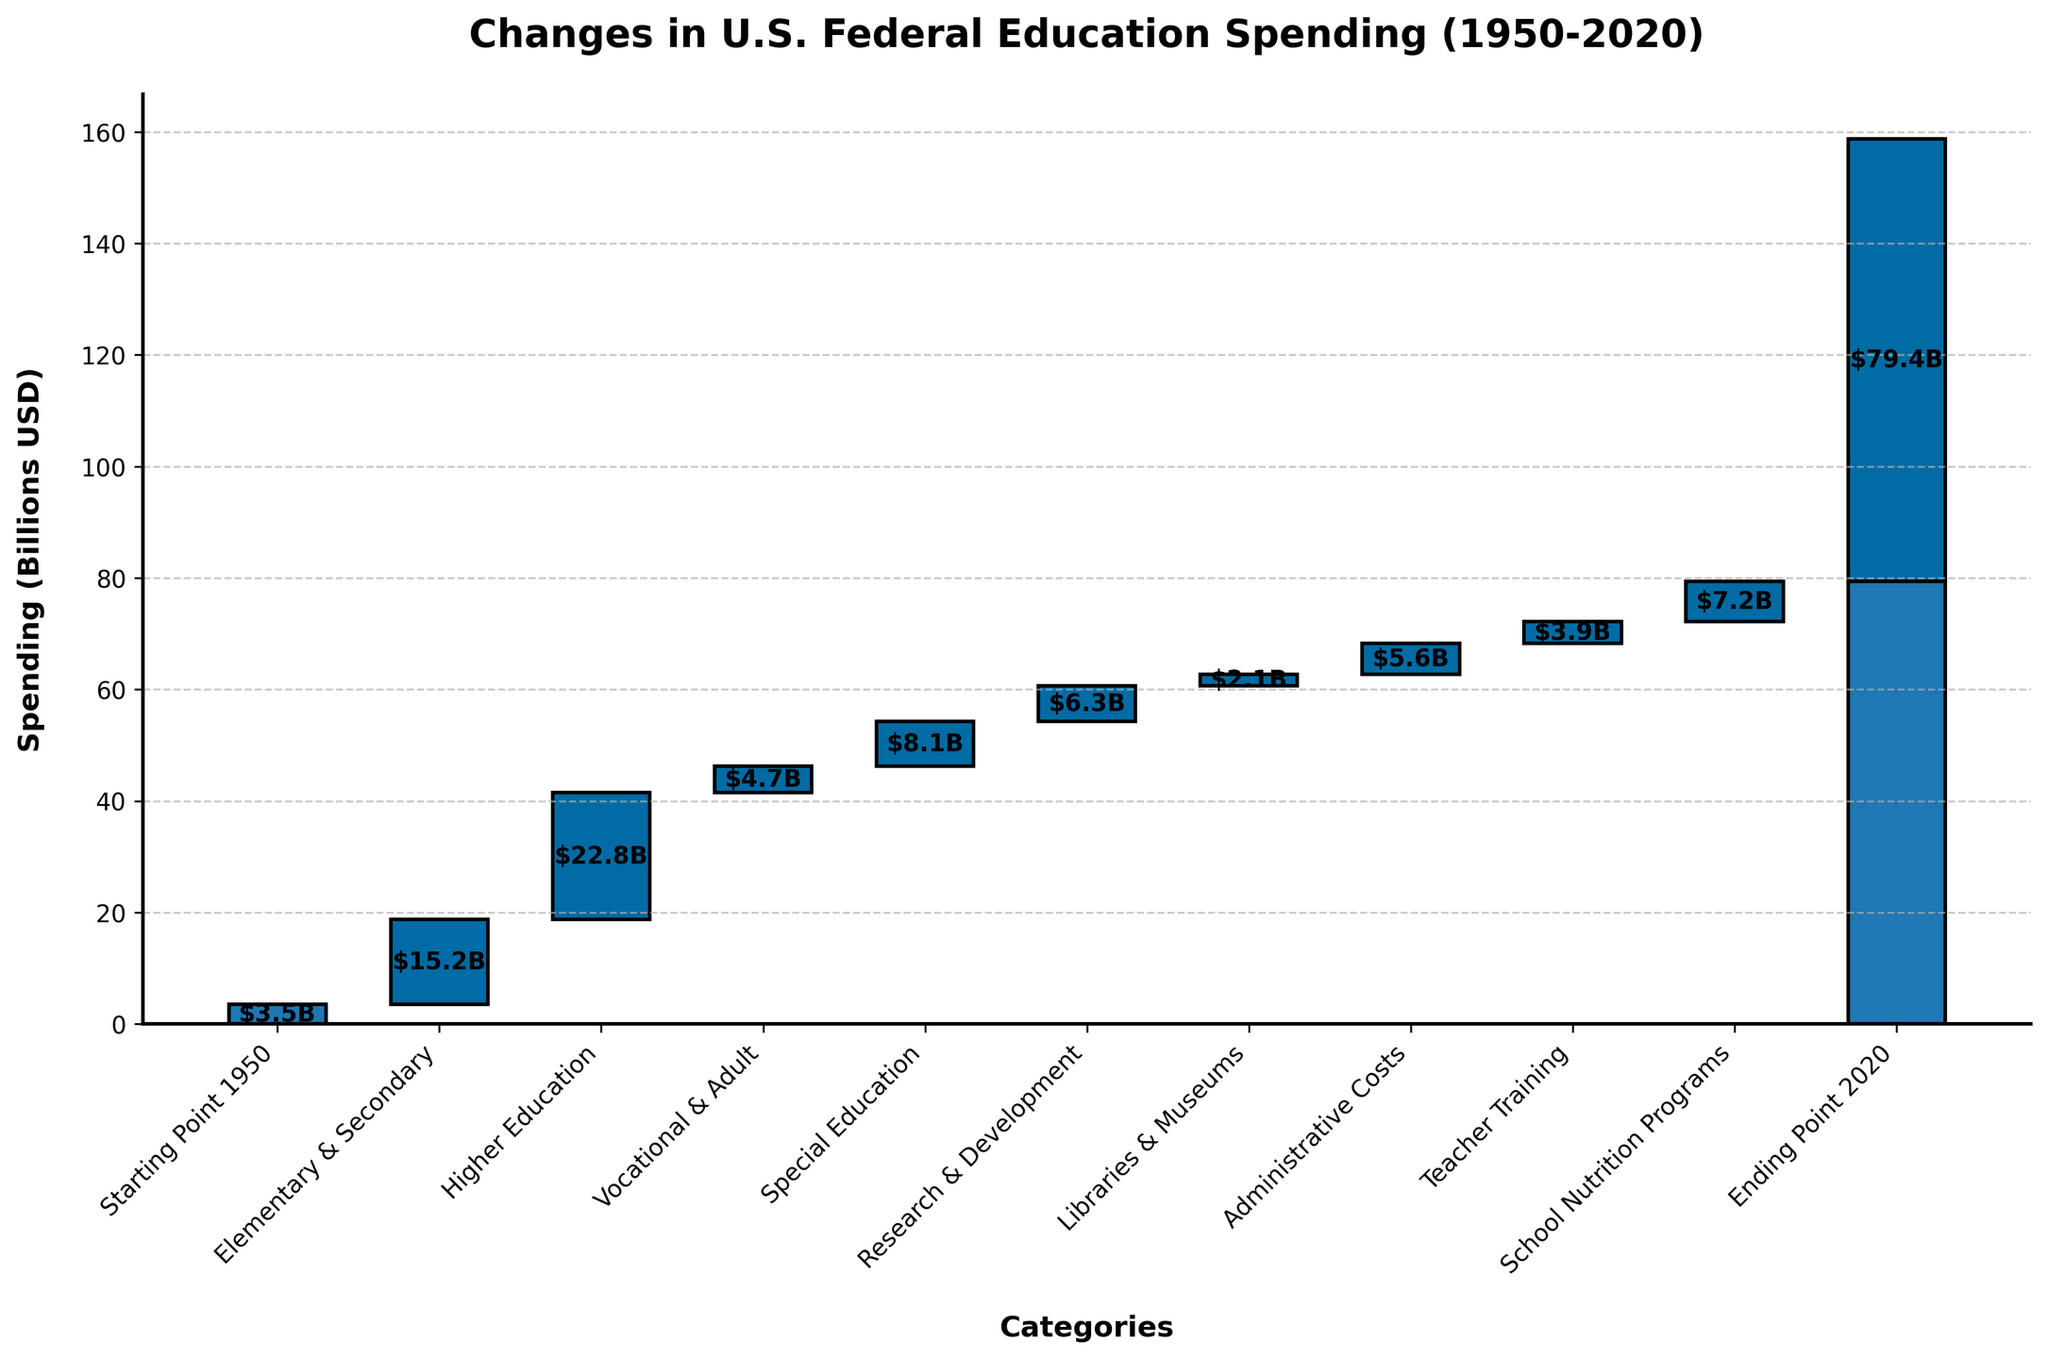What's the title of the chart? The title of the chart is displayed at the top of the figure. It provides the main description of what the chart is about.
Answer: Changes in U.S. Federal Education Spending (1950-2020) What are the starting and ending points of the spending from 1950 to 2020? The starting and ending points can be identified from the first and last bars which are likely highlighted in a different color.
Answer: $3.5B and $79.4B Which educational level category had the highest increase in spending? We look for the bar with the highest value among the categories listed.
Answer: Higher Education What is the cumulative spending for Elementary & Secondary and Higher Education? Find the values for "Elementary & Secondary" and "Higher Education", and sum them up: $15.2B + $22.8B.
Answer: $38.0B How much more was spent on Special Education than on Libraries & Museums? Subtract the spending on "Libraries & Museums" from "Special Education": $8.1B - $2.1B.
Answer: $6.0B Among Administrative Costs and Teacher Training, which had the higher spending? Compare the values listed for "Administrative Costs" and "Teacher Training".
Answer: Administrative Costs What is the total spending across all categories except for the starting and ending points? Sum the values of all categories except "Starting Point 1950" and "Ending Point 2020": $15.2B + $22.8B + $4.7B + $8.1B + $6.3B + $2.1B + $5.6B + $3.9B + $7.2B.
Answer: $75.9B Which category had the smallest increase in spending? Look for the smallest bar value among the categories listed.
Answer: Libraries & Museums What percentage of the total increase in spending (1950-2020) is attributed to School Nutrition Programs? Calculate the percentage by dividing the spending on "School Nutrition Programs" by the total increase ($79.4B - $3.5B): $7.2B / $75.9B * 100.
Answer: 9.48% How much did vocational and adult education spending change? The value for "Vocational & Adult" directly indicates the spending change for that category.
Answer: $4.7B 